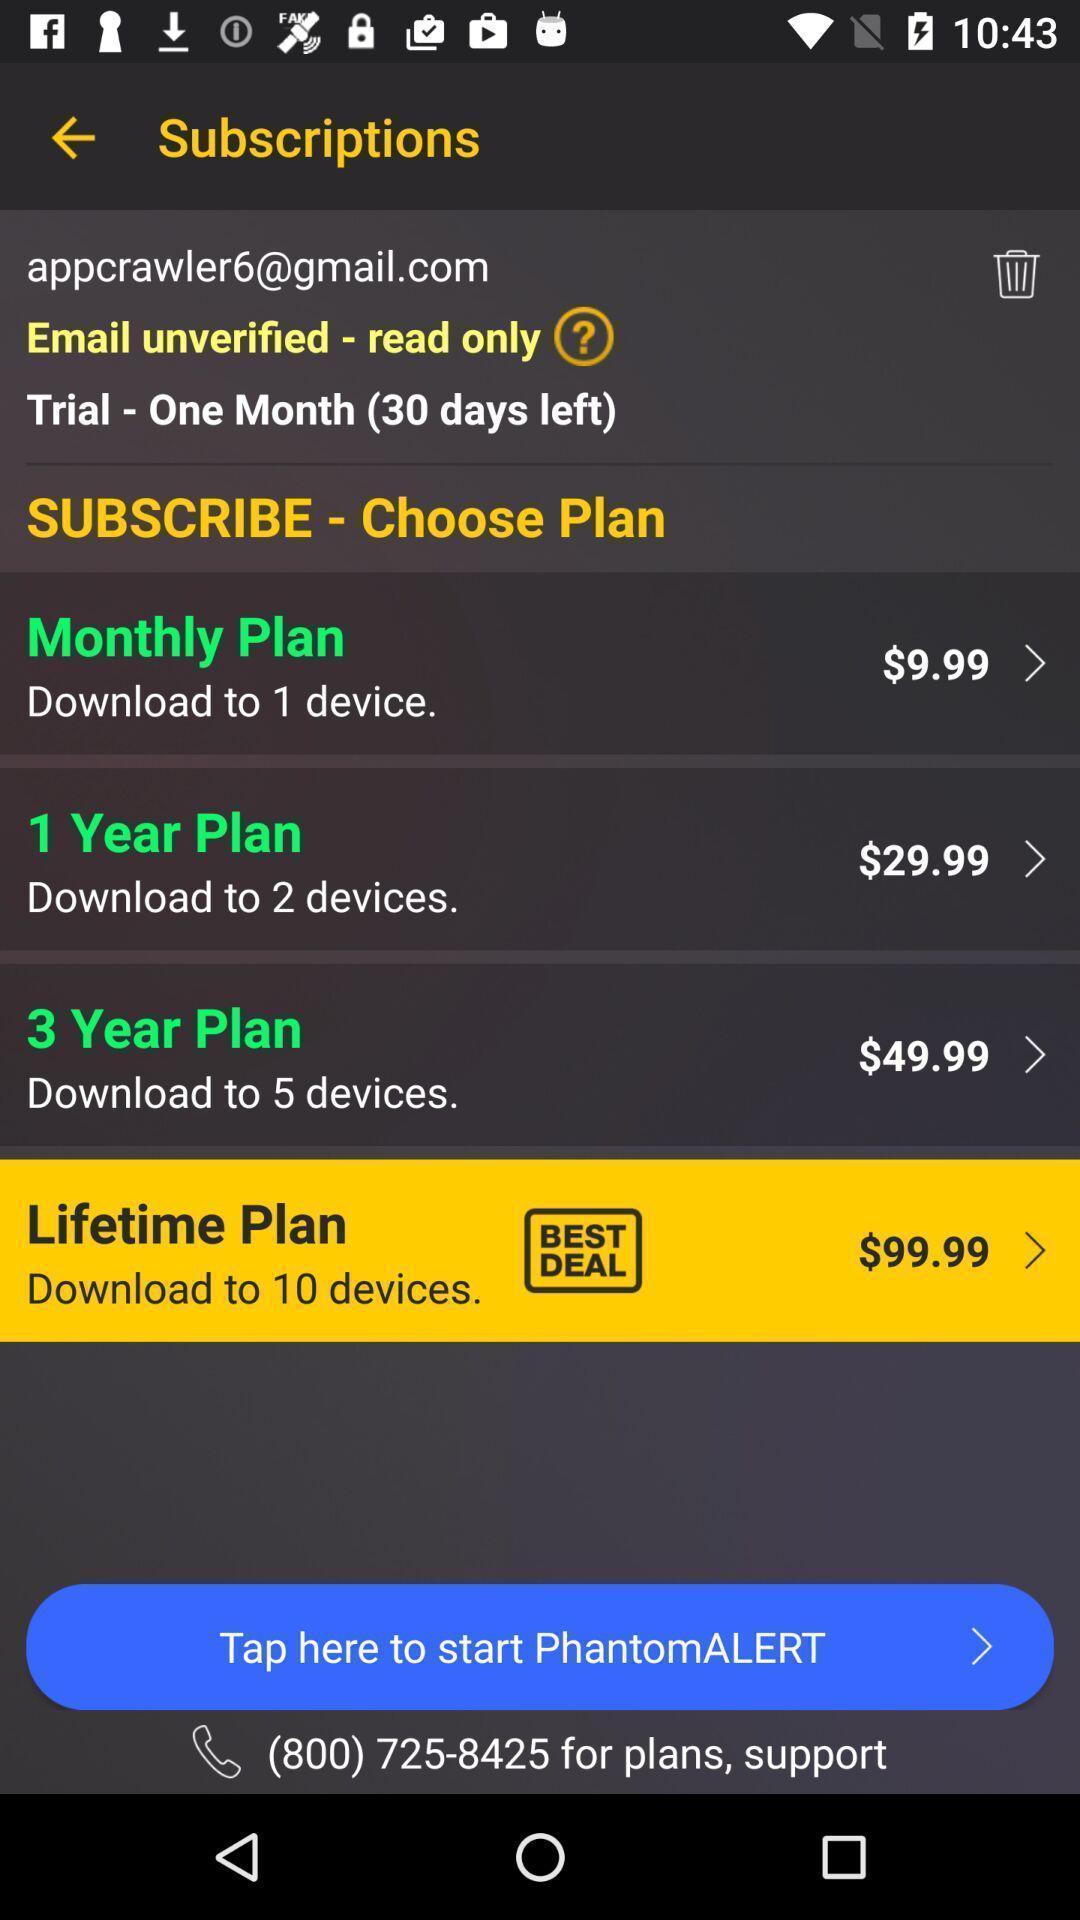Explain what's happening in this screen capture. Screen display subscriptions page. 